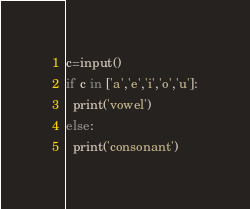Convert code to text. <code><loc_0><loc_0><loc_500><loc_500><_Python_>c=input()
if c in ['a','e','i','o','u']:
  print('vowel')
else:
  print('consonant')</code> 